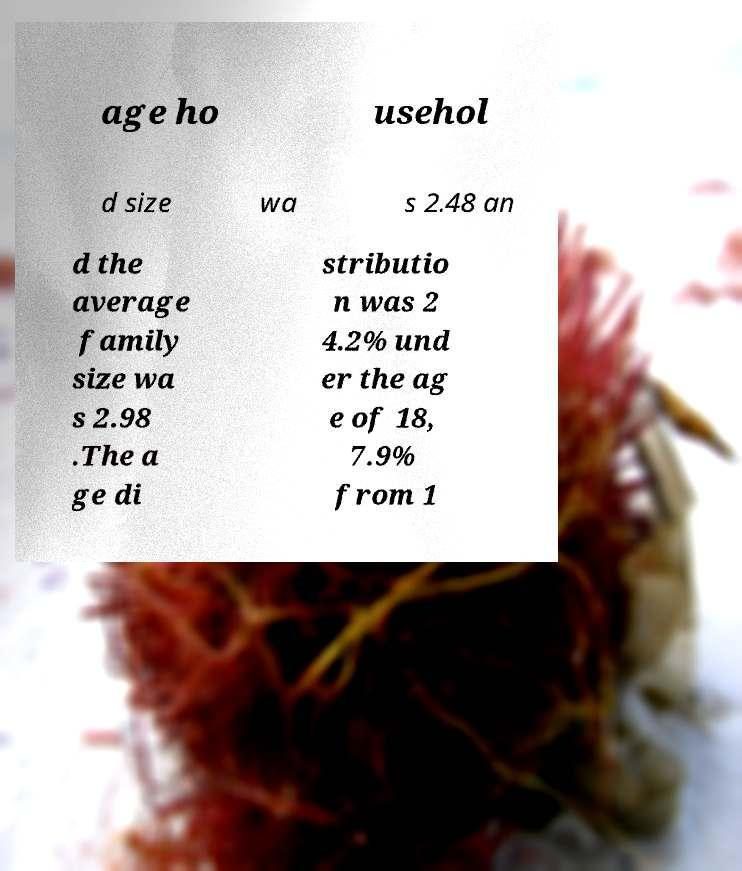Could you assist in decoding the text presented in this image and type it out clearly? age ho usehol d size wa s 2.48 an d the average family size wa s 2.98 .The a ge di stributio n was 2 4.2% und er the ag e of 18, 7.9% from 1 